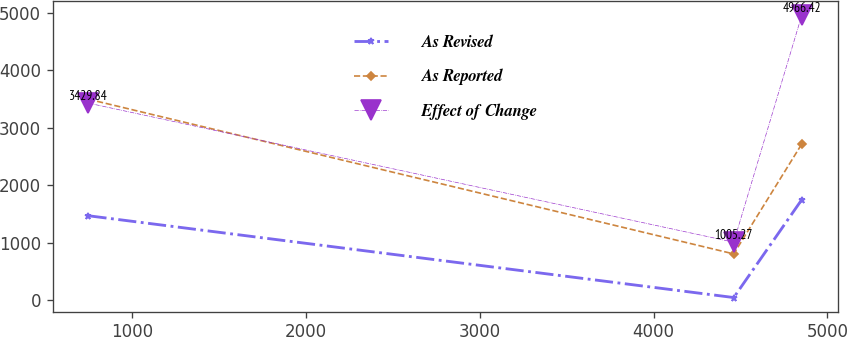Convert chart. <chart><loc_0><loc_0><loc_500><loc_500><line_chart><ecel><fcel>As Revised<fcel>As Reported<fcel>Effect of Change<nl><fcel>746.72<fcel>1466.38<fcel>3498.1<fcel>3429.84<nl><fcel>4461.12<fcel>40.63<fcel>801.18<fcel>1005.27<nl><fcel>4853.31<fcel>1749.42<fcel>2720.01<fcel>4966.42<nl></chart> 